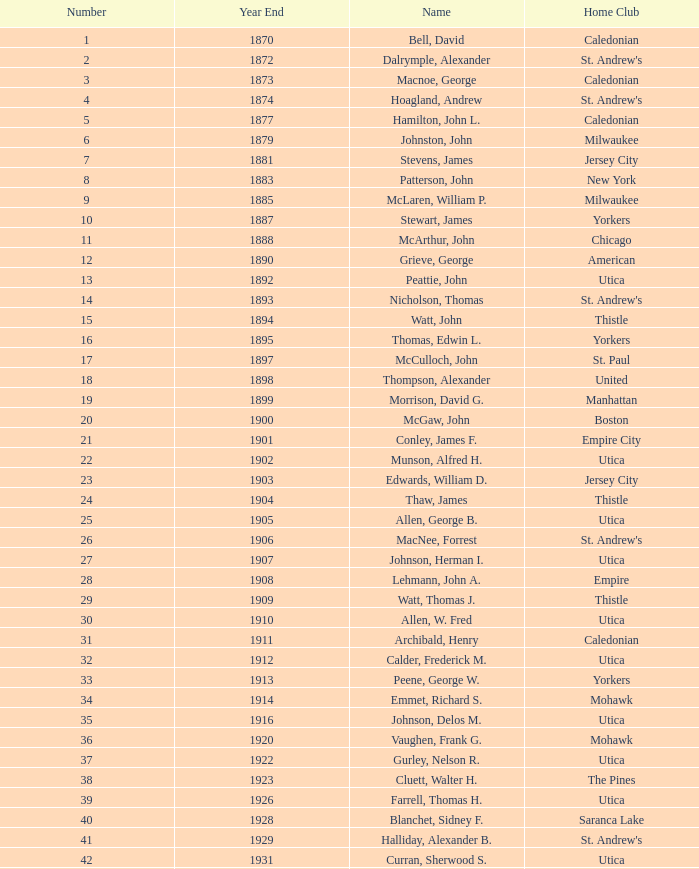Which Number has a Name of hill, lucius t.? 53.0. 